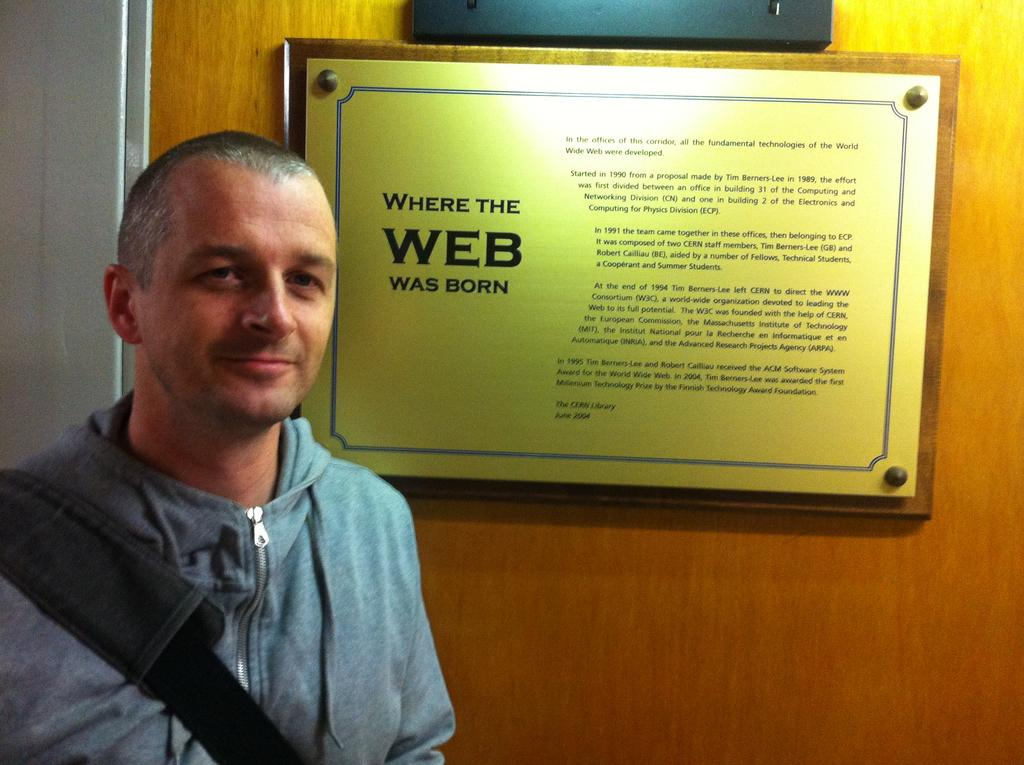What is the main subject of the image? There is a person standing in the image. Can you describe what the person is wearing? The person is wearing a bag. What else can be seen in the image besides the person? There is a text board attached to a wooden door, and there is an object attached to the door. Can you see a ghost interacting with the person in the image? There is no ghost present in the image. What type of tin is visible on the text board? There is no tin present on the text board or in the image. 